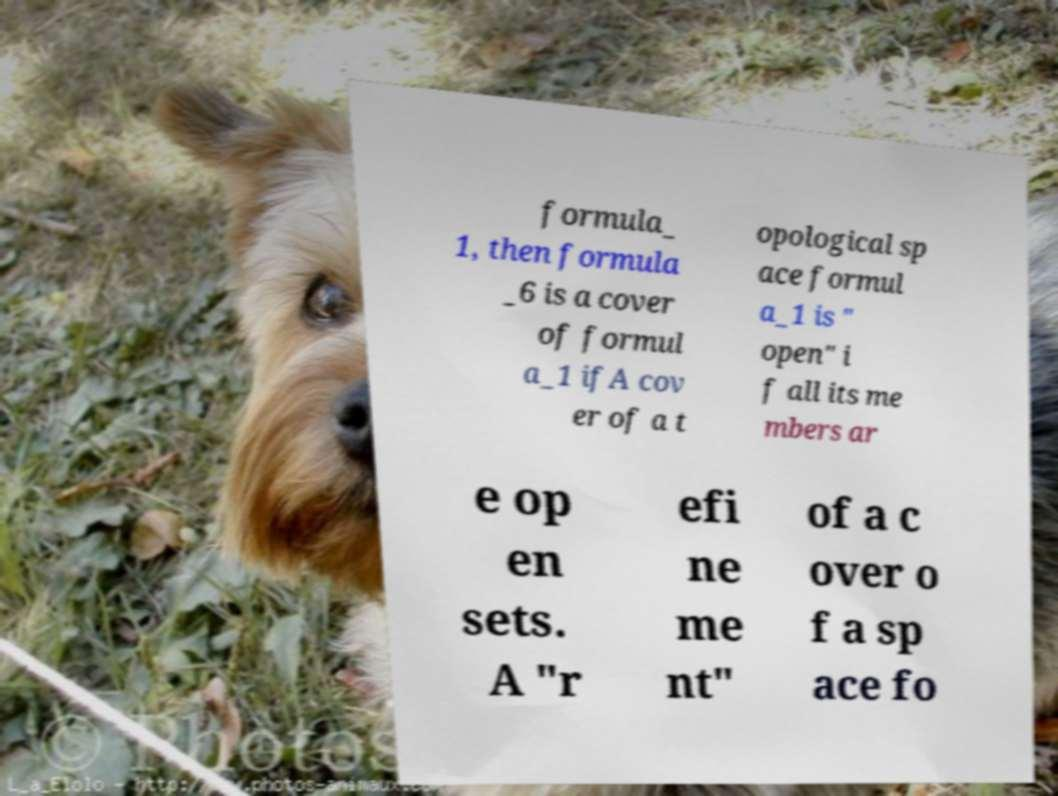Can you read and provide the text displayed in the image?This photo seems to have some interesting text. Can you extract and type it out for me? formula_ 1, then formula _6 is a cover of formul a_1 ifA cov er of a t opological sp ace formul a_1 is " open" i f all its me mbers ar e op en sets. A "r efi ne me nt" of a c over o f a sp ace fo 